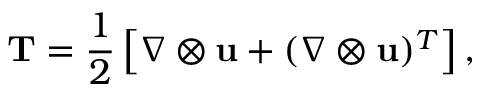Convert formula to latex. <formula><loc_0><loc_0><loc_500><loc_500>T = \frac { 1 } { 2 } \left [ \nabla \otimes u + ( \nabla \otimes u ) ^ { T } \right ] ,</formula> 